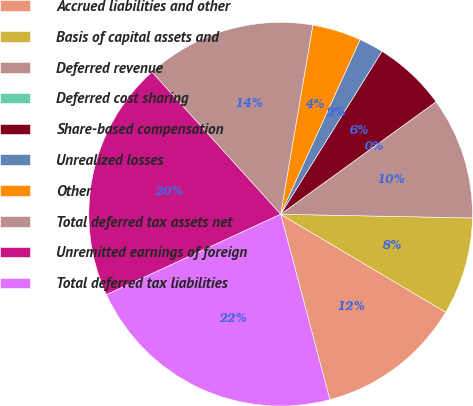<chart> <loc_0><loc_0><loc_500><loc_500><pie_chart><fcel>Accrued liabilities and other<fcel>Basis of capital assets and<fcel>Deferred revenue<fcel>Deferred cost sharing<fcel>Share-based compensation<fcel>Unrealized losses<fcel>Other<fcel>Total deferred tax assets net<fcel>Unremitted earnings of foreign<fcel>Total deferred tax liabilities<nl><fcel>12.34%<fcel>8.22%<fcel>10.28%<fcel>0.0%<fcel>6.17%<fcel>2.06%<fcel>4.11%<fcel>14.39%<fcel>20.18%<fcel>22.24%<nl></chart> 